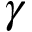<formula> <loc_0><loc_0><loc_500><loc_500>\gamma</formula> 